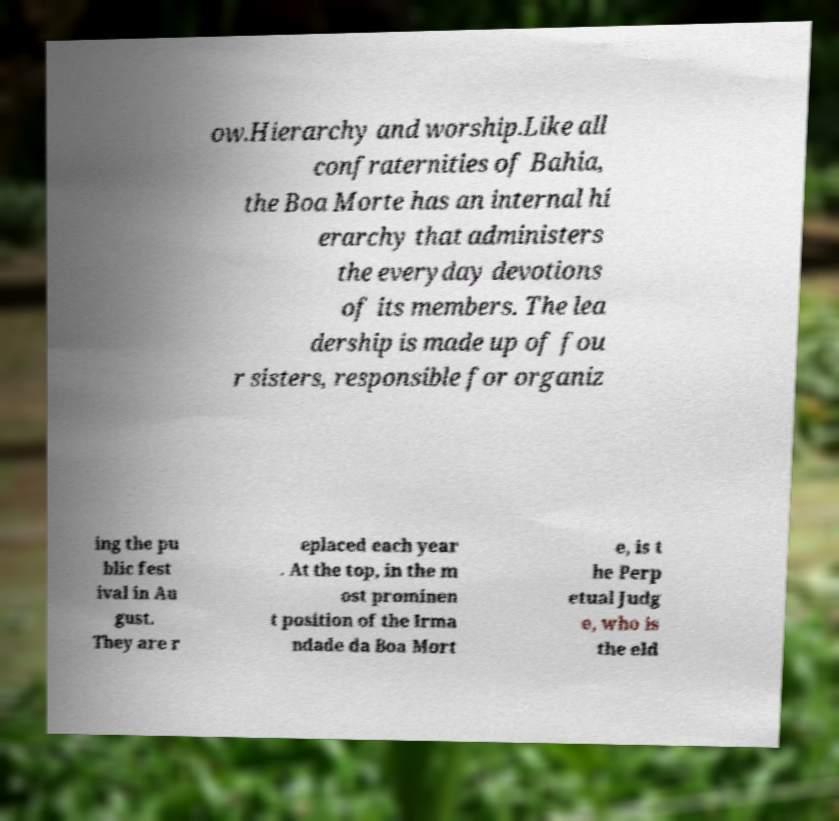Can you accurately transcribe the text from the provided image for me? ow.Hierarchy and worship.Like all confraternities of Bahia, the Boa Morte has an internal hi erarchy that administers the everyday devotions of its members. The lea dership is made up of fou r sisters, responsible for organiz ing the pu blic fest ival in Au gust. They are r eplaced each year . At the top, in the m ost prominen t position of the Irma ndade da Boa Mort e, is t he Perp etual Judg e, who is the eld 